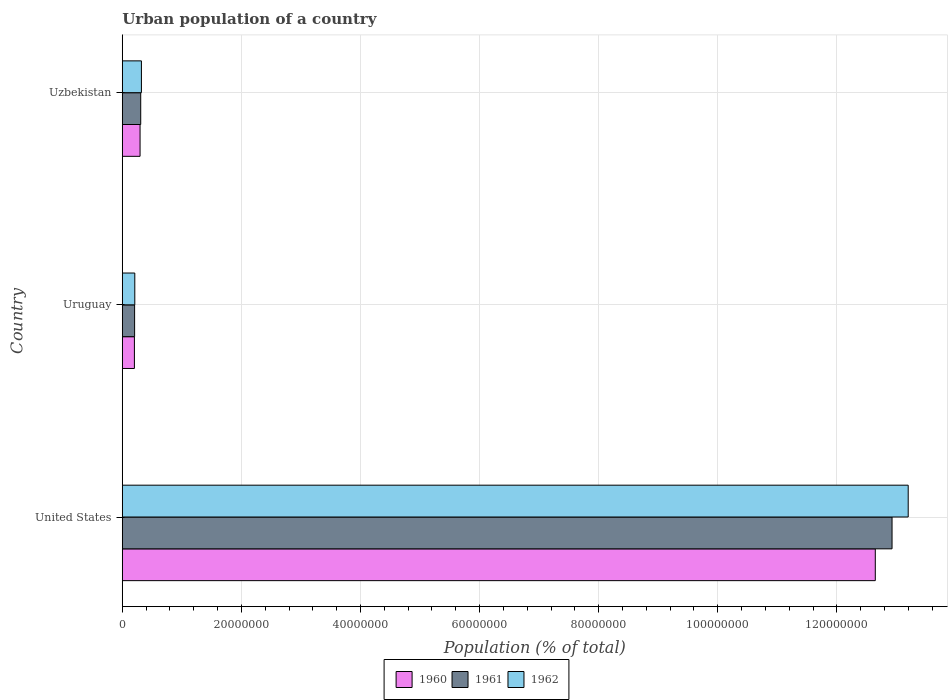How many different coloured bars are there?
Your answer should be compact. 3. Are the number of bars on each tick of the Y-axis equal?
Your response must be concise. Yes. How many bars are there on the 3rd tick from the top?
Your answer should be compact. 3. What is the label of the 1st group of bars from the top?
Your answer should be compact. Uzbekistan. In how many cases, is the number of bars for a given country not equal to the number of legend labels?
Make the answer very short. 0. What is the urban population in 1960 in Uruguay?
Keep it short and to the point. 2.04e+06. Across all countries, what is the maximum urban population in 1960?
Provide a succinct answer. 1.26e+08. Across all countries, what is the minimum urban population in 1962?
Make the answer very short. 2.10e+06. In which country was the urban population in 1961 minimum?
Your response must be concise. Uruguay. What is the total urban population in 1961 in the graph?
Ensure brevity in your answer.  1.34e+08. What is the difference between the urban population in 1961 in United States and that in Uruguay?
Provide a short and direct response. 1.27e+08. What is the difference between the urban population in 1960 in Uzbekistan and the urban population in 1961 in Uruguay?
Provide a short and direct response. 9.17e+05. What is the average urban population in 1962 per country?
Your answer should be compact. 4.58e+07. What is the difference between the urban population in 1960 and urban population in 1962 in United States?
Ensure brevity in your answer.  -5.53e+06. In how many countries, is the urban population in 1962 greater than 112000000 %?
Your response must be concise. 1. What is the ratio of the urban population in 1961 in United States to that in Uzbekistan?
Offer a very short reply. 41.75. Is the urban population in 1961 in United States less than that in Uzbekistan?
Make the answer very short. No. Is the difference between the urban population in 1960 in Uruguay and Uzbekistan greater than the difference between the urban population in 1962 in Uruguay and Uzbekistan?
Keep it short and to the point. Yes. What is the difference between the highest and the second highest urban population in 1960?
Give a very brief answer. 1.23e+08. What is the difference between the highest and the lowest urban population in 1962?
Provide a succinct answer. 1.30e+08. How many bars are there?
Your response must be concise. 9. Are all the bars in the graph horizontal?
Your answer should be compact. Yes. How many countries are there in the graph?
Ensure brevity in your answer.  3. Are the values on the major ticks of X-axis written in scientific E-notation?
Ensure brevity in your answer.  No. Does the graph contain grids?
Ensure brevity in your answer.  Yes. Where does the legend appear in the graph?
Your response must be concise. Bottom center. What is the title of the graph?
Your answer should be compact. Urban population of a country. Does "2007" appear as one of the legend labels in the graph?
Make the answer very short. No. What is the label or title of the X-axis?
Provide a succinct answer. Population (% of total). What is the label or title of the Y-axis?
Make the answer very short. Country. What is the Population (% of total) in 1960 in United States?
Provide a succinct answer. 1.26e+08. What is the Population (% of total) of 1961 in United States?
Provide a succinct answer. 1.29e+08. What is the Population (% of total) of 1962 in United States?
Make the answer very short. 1.32e+08. What is the Population (% of total) in 1960 in Uruguay?
Your response must be concise. 2.04e+06. What is the Population (% of total) in 1961 in Uruguay?
Ensure brevity in your answer.  2.07e+06. What is the Population (% of total) of 1962 in Uruguay?
Provide a succinct answer. 2.10e+06. What is the Population (% of total) in 1960 in Uzbekistan?
Your answer should be very brief. 2.99e+06. What is the Population (% of total) in 1961 in Uzbekistan?
Offer a terse response. 3.10e+06. What is the Population (% of total) in 1962 in Uzbekistan?
Give a very brief answer. 3.22e+06. Across all countries, what is the maximum Population (% of total) in 1960?
Your response must be concise. 1.26e+08. Across all countries, what is the maximum Population (% of total) in 1961?
Make the answer very short. 1.29e+08. Across all countries, what is the maximum Population (% of total) of 1962?
Keep it short and to the point. 1.32e+08. Across all countries, what is the minimum Population (% of total) of 1960?
Your answer should be very brief. 2.04e+06. Across all countries, what is the minimum Population (% of total) of 1961?
Keep it short and to the point. 2.07e+06. Across all countries, what is the minimum Population (% of total) in 1962?
Keep it short and to the point. 2.10e+06. What is the total Population (% of total) of 1960 in the graph?
Make the answer very short. 1.31e+08. What is the total Population (% of total) in 1961 in the graph?
Make the answer very short. 1.34e+08. What is the total Population (% of total) in 1962 in the graph?
Offer a terse response. 1.37e+08. What is the difference between the Population (% of total) in 1960 in United States and that in Uruguay?
Provide a succinct answer. 1.24e+08. What is the difference between the Population (% of total) of 1961 in United States and that in Uruguay?
Keep it short and to the point. 1.27e+08. What is the difference between the Population (% of total) of 1962 in United States and that in Uruguay?
Give a very brief answer. 1.30e+08. What is the difference between the Population (% of total) of 1960 in United States and that in Uzbekistan?
Offer a very short reply. 1.23e+08. What is the difference between the Population (% of total) in 1961 in United States and that in Uzbekistan?
Provide a succinct answer. 1.26e+08. What is the difference between the Population (% of total) in 1962 in United States and that in Uzbekistan?
Your answer should be compact. 1.29e+08. What is the difference between the Population (% of total) in 1960 in Uruguay and that in Uzbekistan?
Offer a very short reply. -9.49e+05. What is the difference between the Population (% of total) in 1961 in Uruguay and that in Uzbekistan?
Provide a succinct answer. -1.03e+06. What is the difference between the Population (% of total) of 1962 in Uruguay and that in Uzbekistan?
Provide a short and direct response. -1.11e+06. What is the difference between the Population (% of total) in 1960 in United States and the Population (% of total) in 1961 in Uruguay?
Ensure brevity in your answer.  1.24e+08. What is the difference between the Population (% of total) in 1960 in United States and the Population (% of total) in 1962 in Uruguay?
Your answer should be compact. 1.24e+08. What is the difference between the Population (% of total) of 1961 in United States and the Population (% of total) of 1962 in Uruguay?
Ensure brevity in your answer.  1.27e+08. What is the difference between the Population (% of total) in 1960 in United States and the Population (% of total) in 1961 in Uzbekistan?
Keep it short and to the point. 1.23e+08. What is the difference between the Population (% of total) of 1960 in United States and the Population (% of total) of 1962 in Uzbekistan?
Your answer should be compact. 1.23e+08. What is the difference between the Population (% of total) in 1961 in United States and the Population (% of total) in 1962 in Uzbekistan?
Provide a succinct answer. 1.26e+08. What is the difference between the Population (% of total) of 1960 in Uruguay and the Population (% of total) of 1961 in Uzbekistan?
Offer a very short reply. -1.06e+06. What is the difference between the Population (% of total) of 1960 in Uruguay and the Population (% of total) of 1962 in Uzbekistan?
Offer a very short reply. -1.18e+06. What is the difference between the Population (% of total) of 1961 in Uruguay and the Population (% of total) of 1962 in Uzbekistan?
Give a very brief answer. -1.15e+06. What is the average Population (% of total) of 1960 per country?
Make the answer very short. 4.38e+07. What is the average Population (% of total) in 1961 per country?
Give a very brief answer. 4.48e+07. What is the average Population (% of total) in 1962 per country?
Your answer should be compact. 4.58e+07. What is the difference between the Population (% of total) in 1960 and Population (% of total) in 1961 in United States?
Offer a very short reply. -2.81e+06. What is the difference between the Population (% of total) in 1960 and Population (% of total) in 1962 in United States?
Keep it short and to the point. -5.53e+06. What is the difference between the Population (% of total) in 1961 and Population (% of total) in 1962 in United States?
Provide a short and direct response. -2.71e+06. What is the difference between the Population (% of total) of 1960 and Population (% of total) of 1961 in Uruguay?
Keep it short and to the point. -3.22e+04. What is the difference between the Population (% of total) of 1960 and Population (% of total) of 1962 in Uruguay?
Ensure brevity in your answer.  -6.38e+04. What is the difference between the Population (% of total) in 1961 and Population (% of total) in 1962 in Uruguay?
Ensure brevity in your answer.  -3.16e+04. What is the difference between the Population (% of total) in 1960 and Population (% of total) in 1961 in Uzbekistan?
Give a very brief answer. -1.10e+05. What is the difference between the Population (% of total) of 1960 and Population (% of total) of 1962 in Uzbekistan?
Give a very brief answer. -2.29e+05. What is the difference between the Population (% of total) of 1961 and Population (% of total) of 1962 in Uzbekistan?
Your answer should be compact. -1.19e+05. What is the ratio of the Population (% of total) in 1960 in United States to that in Uruguay?
Offer a terse response. 62.08. What is the ratio of the Population (% of total) of 1961 in United States to that in Uruguay?
Make the answer very short. 62.48. What is the ratio of the Population (% of total) in 1962 in United States to that in Uruguay?
Give a very brief answer. 62.83. What is the ratio of the Population (% of total) of 1960 in United States to that in Uzbekistan?
Ensure brevity in your answer.  42.34. What is the ratio of the Population (% of total) of 1961 in United States to that in Uzbekistan?
Your response must be concise. 41.75. What is the ratio of the Population (% of total) of 1962 in United States to that in Uzbekistan?
Your answer should be very brief. 41.05. What is the ratio of the Population (% of total) of 1960 in Uruguay to that in Uzbekistan?
Offer a terse response. 0.68. What is the ratio of the Population (% of total) of 1961 in Uruguay to that in Uzbekistan?
Offer a terse response. 0.67. What is the ratio of the Population (% of total) in 1962 in Uruguay to that in Uzbekistan?
Your answer should be very brief. 0.65. What is the difference between the highest and the second highest Population (% of total) of 1960?
Offer a very short reply. 1.23e+08. What is the difference between the highest and the second highest Population (% of total) in 1961?
Give a very brief answer. 1.26e+08. What is the difference between the highest and the second highest Population (% of total) of 1962?
Ensure brevity in your answer.  1.29e+08. What is the difference between the highest and the lowest Population (% of total) of 1960?
Give a very brief answer. 1.24e+08. What is the difference between the highest and the lowest Population (% of total) of 1961?
Provide a succinct answer. 1.27e+08. What is the difference between the highest and the lowest Population (% of total) of 1962?
Your response must be concise. 1.30e+08. 